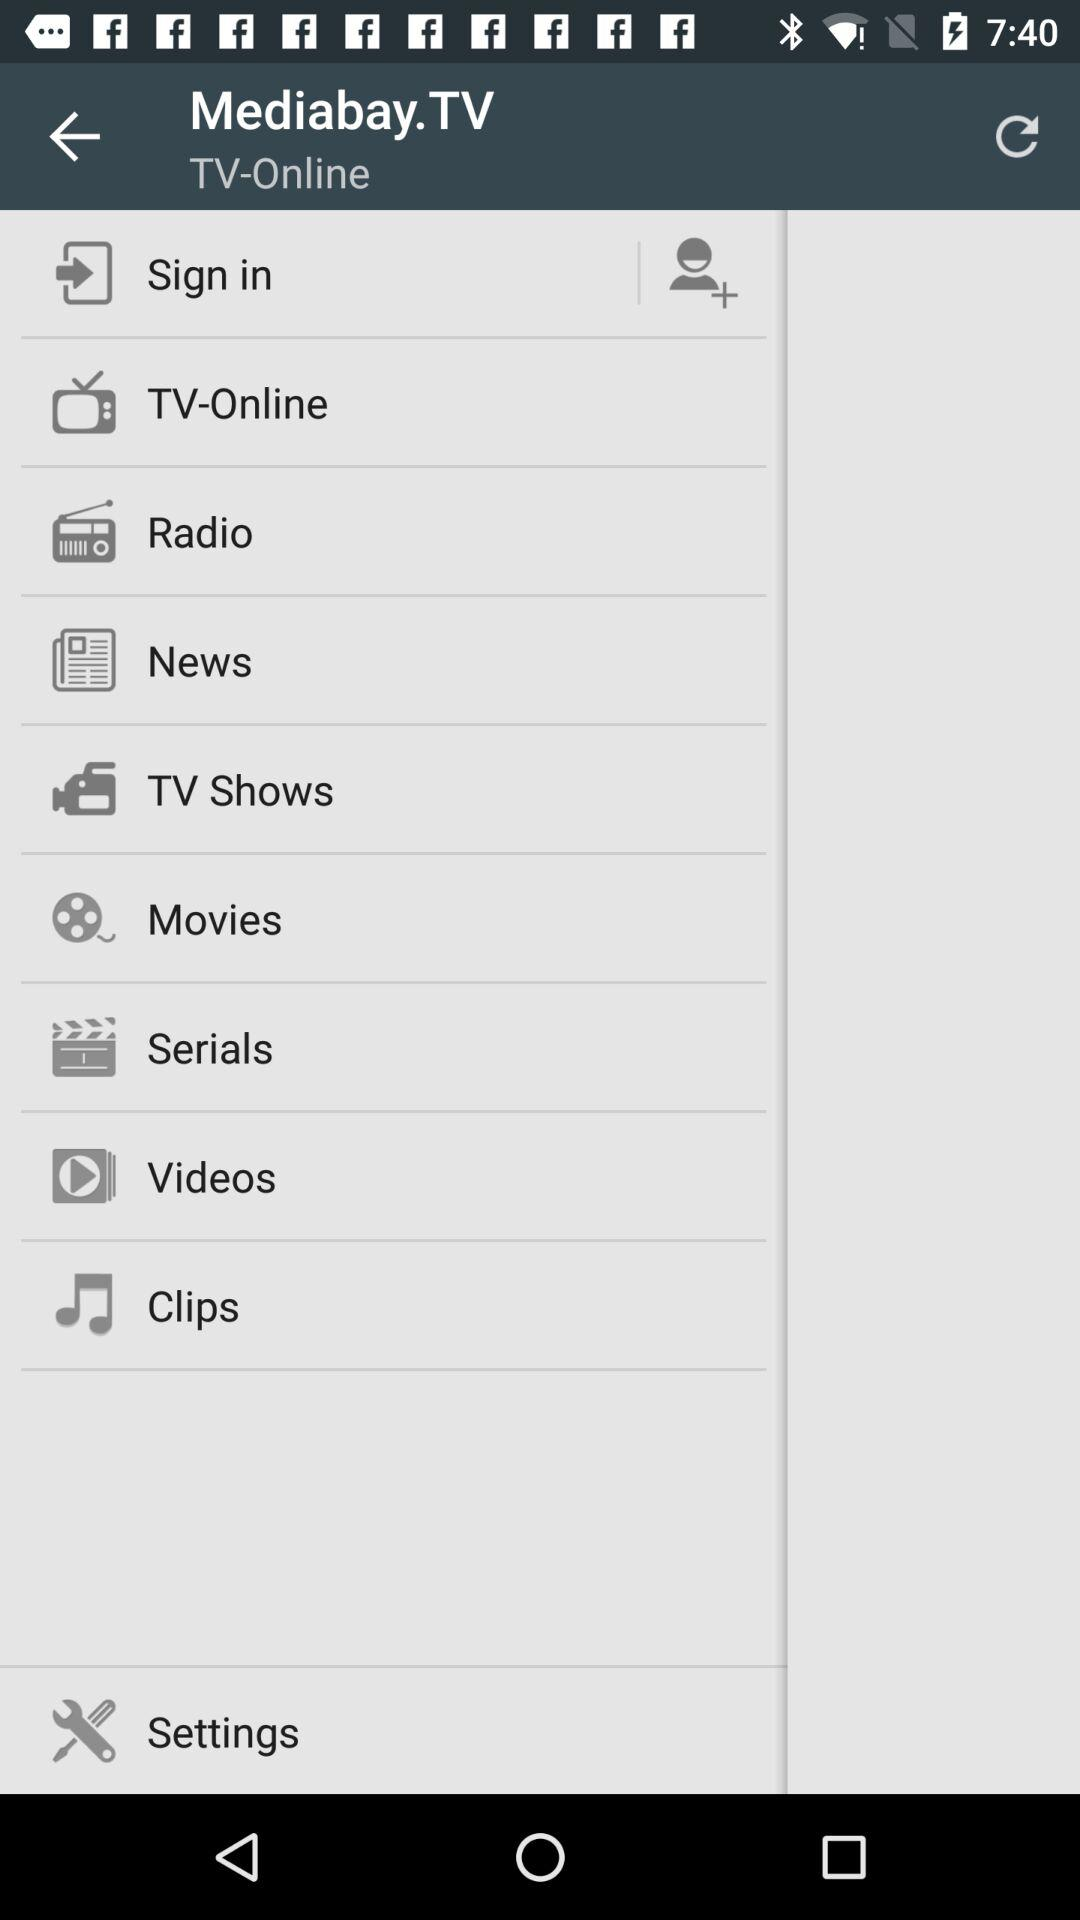What is the application name? The application name is "Mediabay.TV". 